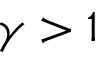Convert formula to latex. <formula><loc_0><loc_0><loc_500><loc_500>\gamma > 1</formula> 